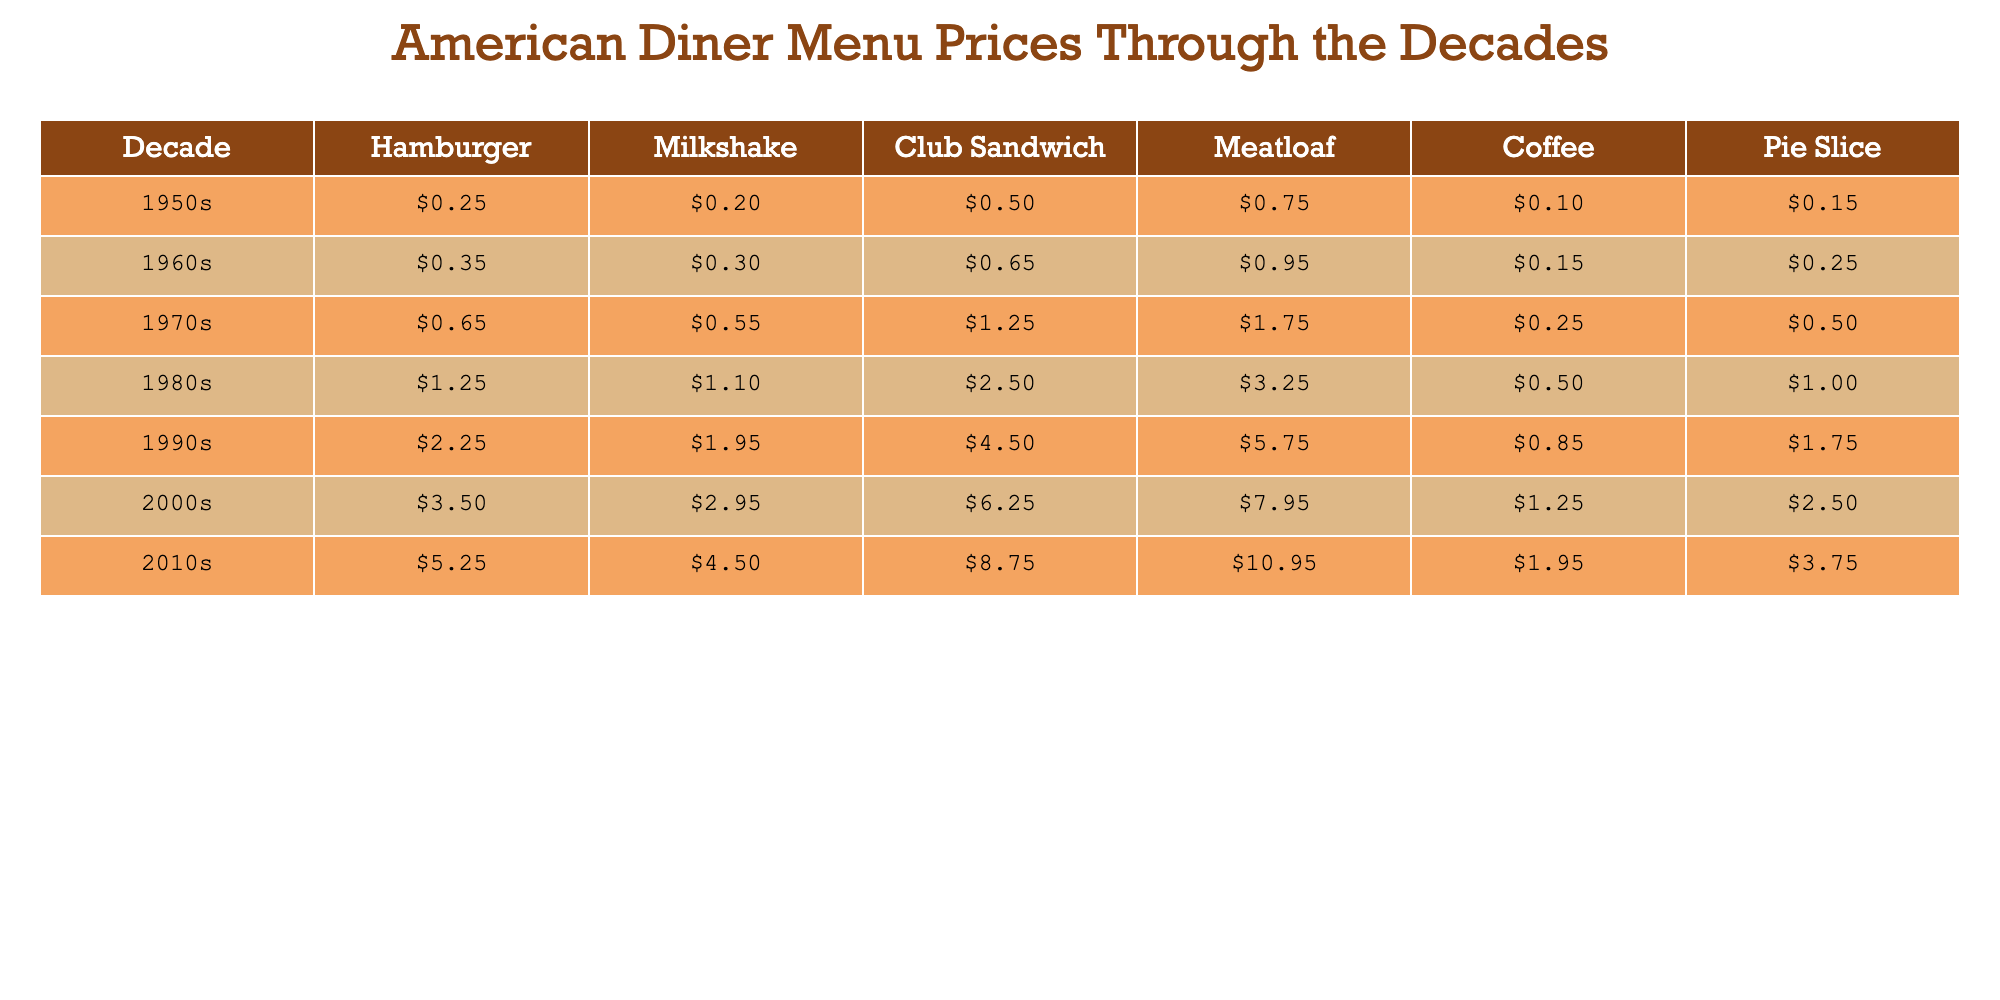What was the price of a hamburger in the 1980s? From the 1980s row, the price of a hamburger is listed as $1.25.
Answer: $1.25 Which decade saw the lowest price for a milkshake? In the table, the milkshake price for the 1950s is $0.20, which is the lowest price when comparing with other decades.
Answer: 1950s What is the average price of coffee across all decades? To find the average, add the coffee prices: $0.10 + $0.15 + $0.25 + $0.50 + $0.85 + $1.25 + $1.95 = $4.05. Then divide by the number of decades (7), resulting in $4.05 / 7 = approximately $0.58.
Answer: $0.58 Was the price of a pie slice ever higher than $3.00? Looking at the pie slice prices, the highest value is $3.75 in the 2010s, confirming that it was higher than $3.00.
Answer: Yes Which menu item had the largest price increase from the 1950s to the 2010s? The hamburger price rose from $0.25 in the 1950s to $5.25 in the 2010s, an increase of $5.00. The meatloaf also increased, from $0.75 to $10.95, a total increase of $10.20. Compare these increases, and the meatloaf has the largest increase.
Answer: Meatloaf What was the percentage increase in price for a club sandwich from the 1970s to the 1990s? The price of a club sandwich increased from $1.25 in the 1970s to $4.50 in the 1990s. Calculate the increase: $4.50 - $1.25 = $3.25. Then, for the percentage increase: ($3.25 / $1.25) * 100 = 260%.
Answer: 260% In which decade was coffee priced at $0.50? By checking the table, the price of coffee was $0.50 in the 1980s, specifically noted in that row.
Answer: 1980s What can be said about the trend of meatloaf prices over the decades? Looking at the table from 1950s to 2010s, prices increased from $0.75 to $10.95, indicating a consistent upward trend over the decades.
Answer: Continuous increase What decade had the highest price for a milkshake? The 2010s show a milkshake price of $4.50, which is the highest among all the decades listed in the table.
Answer: 2010s By how much did the price of pie slice increase from the 1990s to the 2000s? The price of pie slice rose from $1.75 in the 1990s to $2.50 in the 2000s. The increase is calculated as $2.50 - $1.75 = $0.75.
Answer: $0.75 